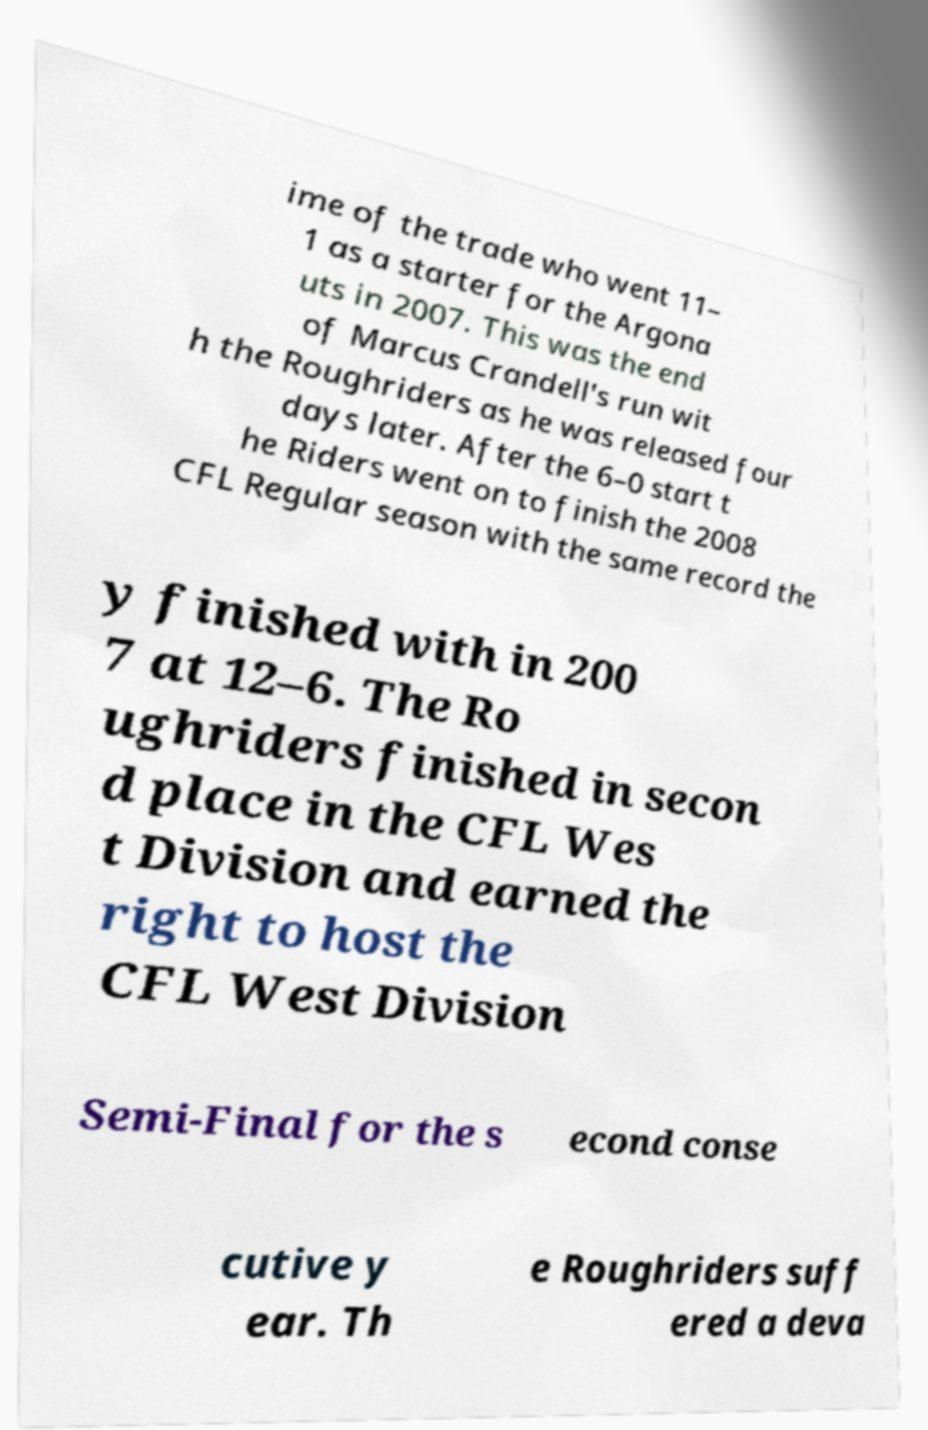Could you assist in decoding the text presented in this image and type it out clearly? ime of the trade who went 11– 1 as a starter for the Argona uts in 2007. This was the end of Marcus Crandell's run wit h the Roughriders as he was released four days later. After the 6–0 start t he Riders went on to finish the 2008 CFL Regular season with the same record the y finished with in 200 7 at 12–6. The Ro ughriders finished in secon d place in the CFL Wes t Division and earned the right to host the CFL West Division Semi-Final for the s econd conse cutive y ear. Th e Roughriders suff ered a deva 